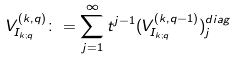<formula> <loc_0><loc_0><loc_500><loc_500>V ^ { ( k , q ) } _ { I _ { k ; q } } \colon = \sum _ { j = 1 } ^ { \infty } t ^ { j - 1 } ( V ^ { ( k , q - 1 ) } _ { I _ { k ; q } } ) ^ { d i a g } _ { j } \,</formula> 